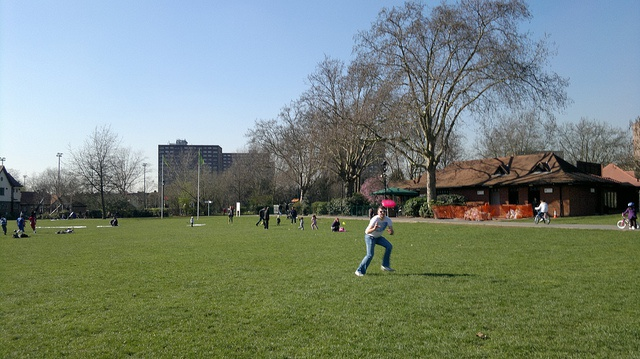Describe the objects in this image and their specific colors. I can see people in lightblue, black, gray, and olive tones, people in lightblue, black, gray, navy, and white tones, people in lightblue, black, purple, and navy tones, people in lightblue, white, gray, black, and darkgray tones, and bicycle in lightblue, gray, black, darkgray, and olive tones in this image. 